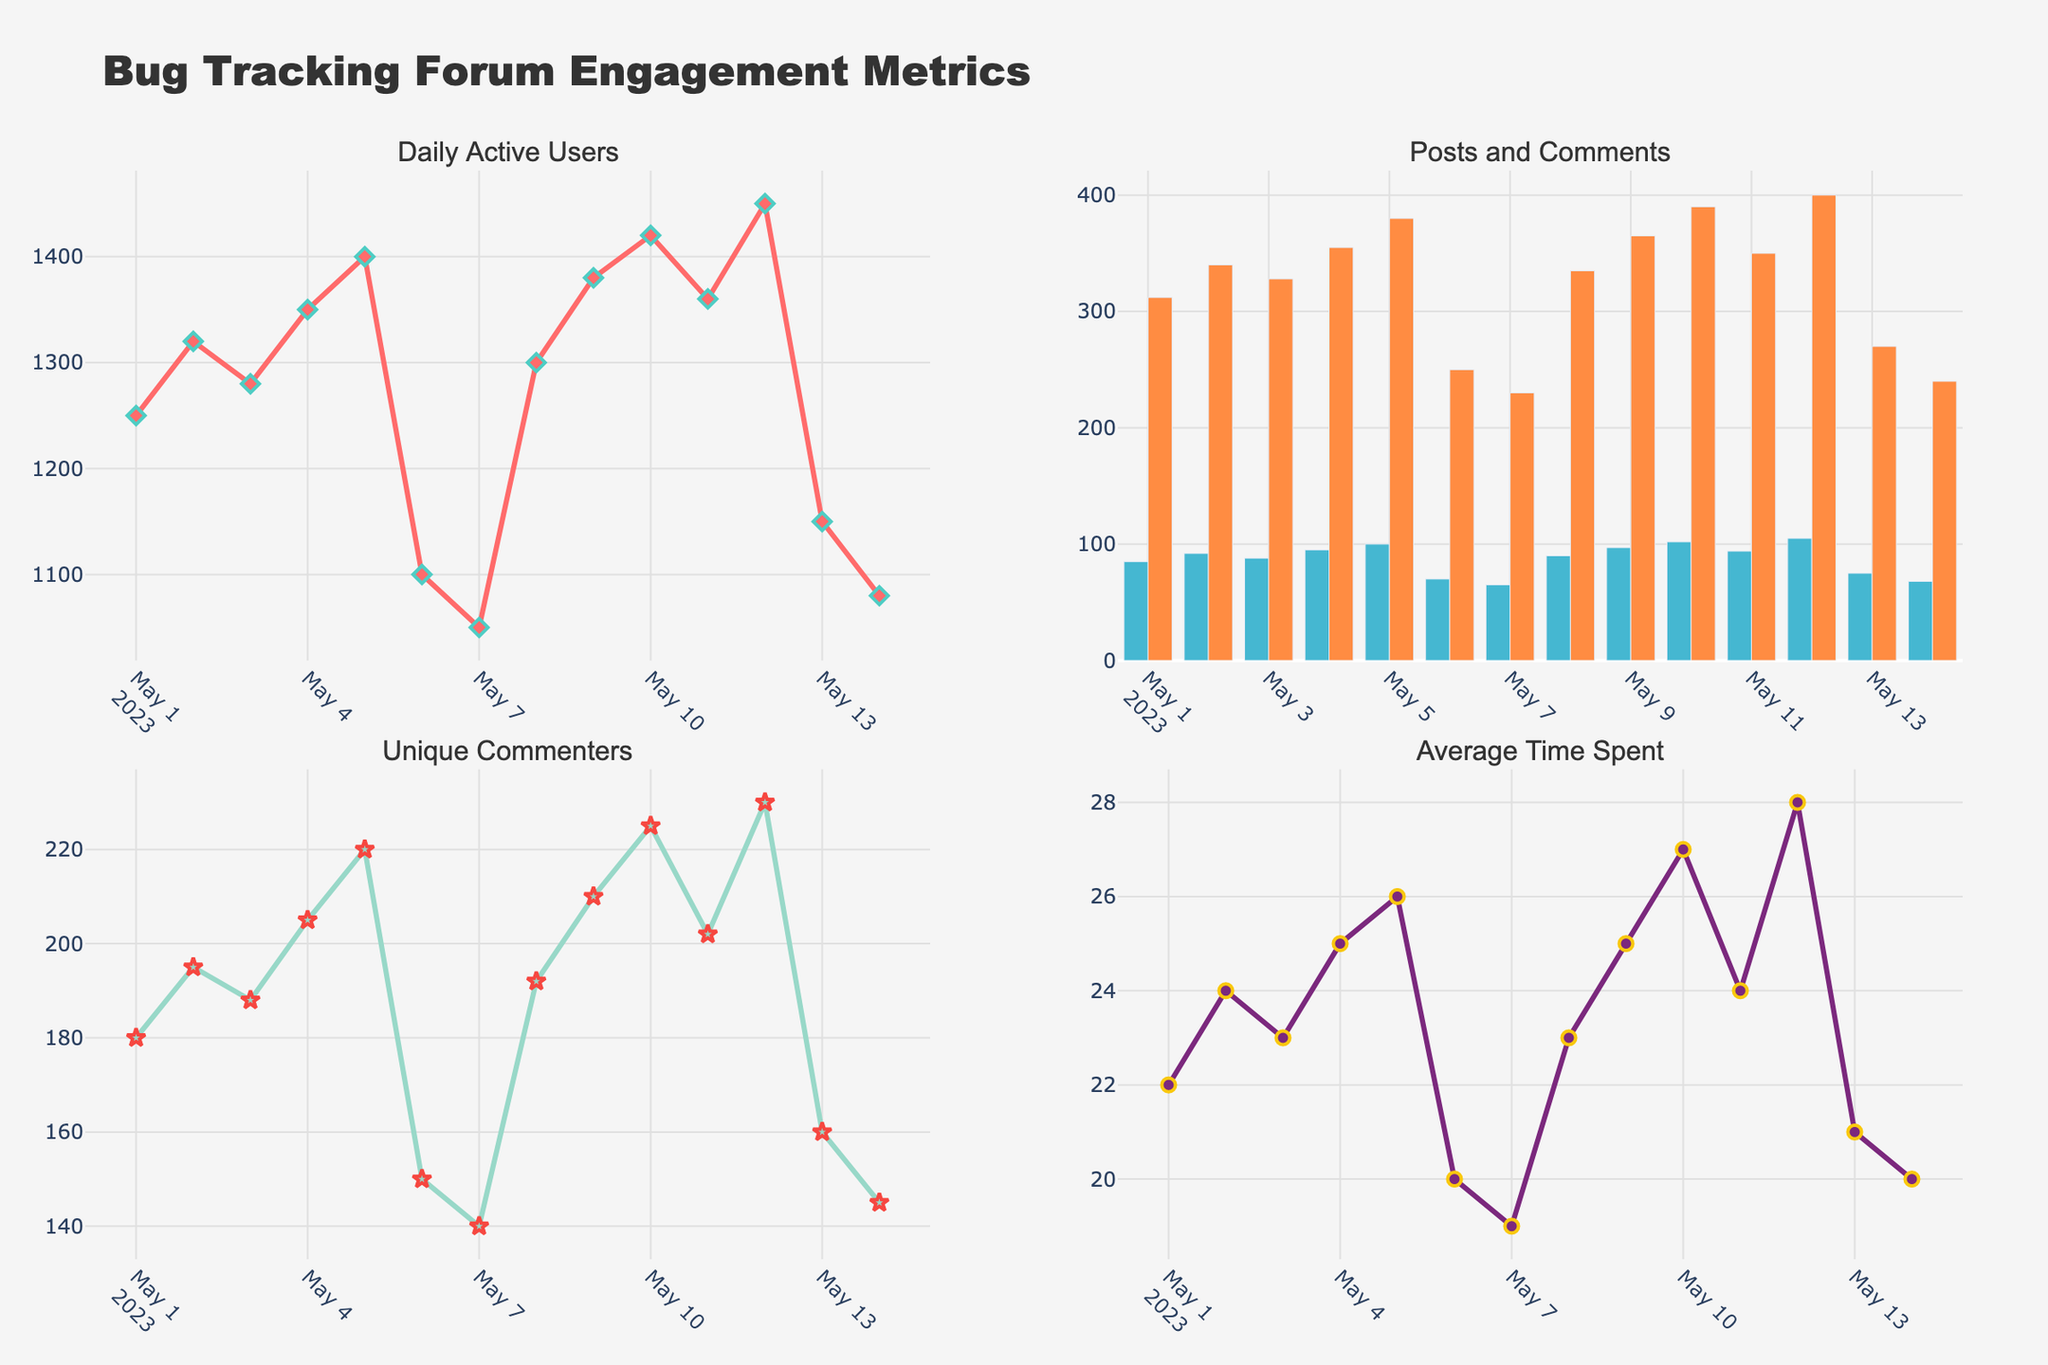What is the title of the entire figure? The title of the entire figure is usually displayed prominently at the top of the chart. According to the code provided, the title should be "Bug Tracking Forum Engagement Metrics".
Answer: Bug Tracking Forum Engagement Metrics What type of chart shows the "Daily Active Users"? The "Daily Active Users" subplot is a scatter plot, indicated by the code creating it with 'lines+markers' mode and markers having a diamond symbol.
Answer: Scatter plot How many posts were made on May 7th, 2023? To find the number of posts on May 7th, 2023, locate the corresponding point in the bar chart for "Posts and Comments". According to the data, there were 65 posts made on this date.
Answer: 65 posts Which day has the highest number of daily active users? To determine the day with the highest number of daily active users, observe the peak in the "Daily Active Users" scatter plot. The data shows that May 12th, 2023, has the highest number of users at 1450.
Answer: May 12th, 2023 How does the comment rate on May 5th compare to the comment rate on May 14th? To compare the comment rates of May 5th and May 14th, observe the height of the bars in the "Posts and Comments" subplot. On May 5th, there are 380 comments, whereas on May 14th, there are 240 comments. Thus, May 5th has a higher comment rate.
Answer: May 5th has a higher comment rate What is the average number of unique commenters over the period? To find the average number of unique commenters over the period, sum the numbers and divide by the total number of days. The sum is 180 + 195 + 188 + 205 + 220 + 150 + 140 + 192 + 210 + 225 + 202 + 230 + 160 + 145 = 2642. There are 14 days, so the average is 2642 / 14 = 188.71.
Answer: 188.71 Which day shows the lowest average time spent on the forum? To determine the day with the lowest average time spent, refer to the scatter plot for "Average Time Spent". The lowest point is on May 7th, 2023, with an average time of 19 minutes.
Answer: May 7th, 2023 Compare the overall trends in "Daily Active Users" and "Average Time Spent". By visually inspecting the "Daily Active Users" and "Average Time Spent" scatter plots, both metrics generally rise and fall simultaneously, indicating a positive correlation: as the daily active users increase, the average time spent also tends to increase.
Answer: Positive correlation What is the total number of comments from May 1st to May 14th, 2023? To calculate the total number of comments, sum the values from the comments column. Total = 312 + 340 + 328 + 355 + 380 + 250 + 230 + 335 + 365 + 390 + 350 + 400 + 270 + 240 = 4545 comments.
Answer: 4545 comments 